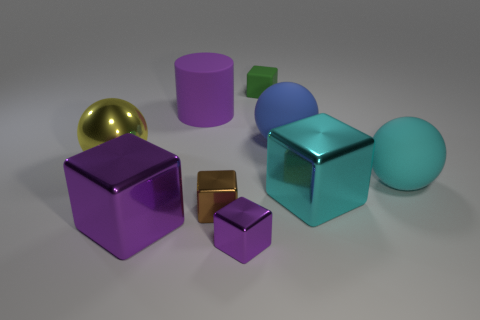Can you describe the texture and materials of the objects in the image? Certainly! The image showcases a variety of objects with differing textures and materials. The cube in the foreground has a smooth, reflective metal surface, hinting at a possibly steel or aluminum construction. The smaller cube and block appear to have a similarly reflective surface, suggesting they are also metallic. In contrast, the sphere and the larger cube seem to have a more matte finish, indicative of a rubber material. The cylinder's surface is somewhere in between, with a less shiny finish, yet it does not seem to be as matte as rubber, possibly a painted metal or plastic. 